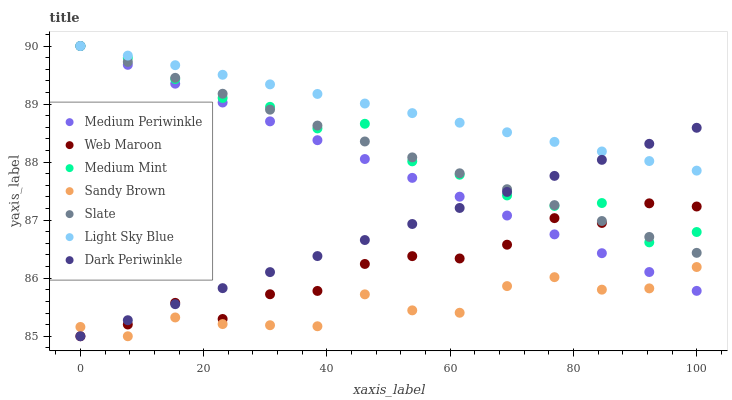Does Sandy Brown have the minimum area under the curve?
Answer yes or no. Yes. Does Light Sky Blue have the maximum area under the curve?
Answer yes or no. Yes. Does Medium Periwinkle have the minimum area under the curve?
Answer yes or no. No. Does Medium Periwinkle have the maximum area under the curve?
Answer yes or no. No. Is Light Sky Blue the smoothest?
Answer yes or no. Yes. Is Web Maroon the roughest?
Answer yes or no. Yes. Is Medium Periwinkle the smoothest?
Answer yes or no. No. Is Medium Periwinkle the roughest?
Answer yes or no. No. Does Web Maroon have the lowest value?
Answer yes or no. Yes. Does Medium Periwinkle have the lowest value?
Answer yes or no. No. Does Light Sky Blue have the highest value?
Answer yes or no. Yes. Does Web Maroon have the highest value?
Answer yes or no. No. Is Sandy Brown less than Slate?
Answer yes or no. Yes. Is Slate greater than Sandy Brown?
Answer yes or no. Yes. Does Medium Mint intersect Dark Periwinkle?
Answer yes or no. Yes. Is Medium Mint less than Dark Periwinkle?
Answer yes or no. No. Is Medium Mint greater than Dark Periwinkle?
Answer yes or no. No. Does Sandy Brown intersect Slate?
Answer yes or no. No. 